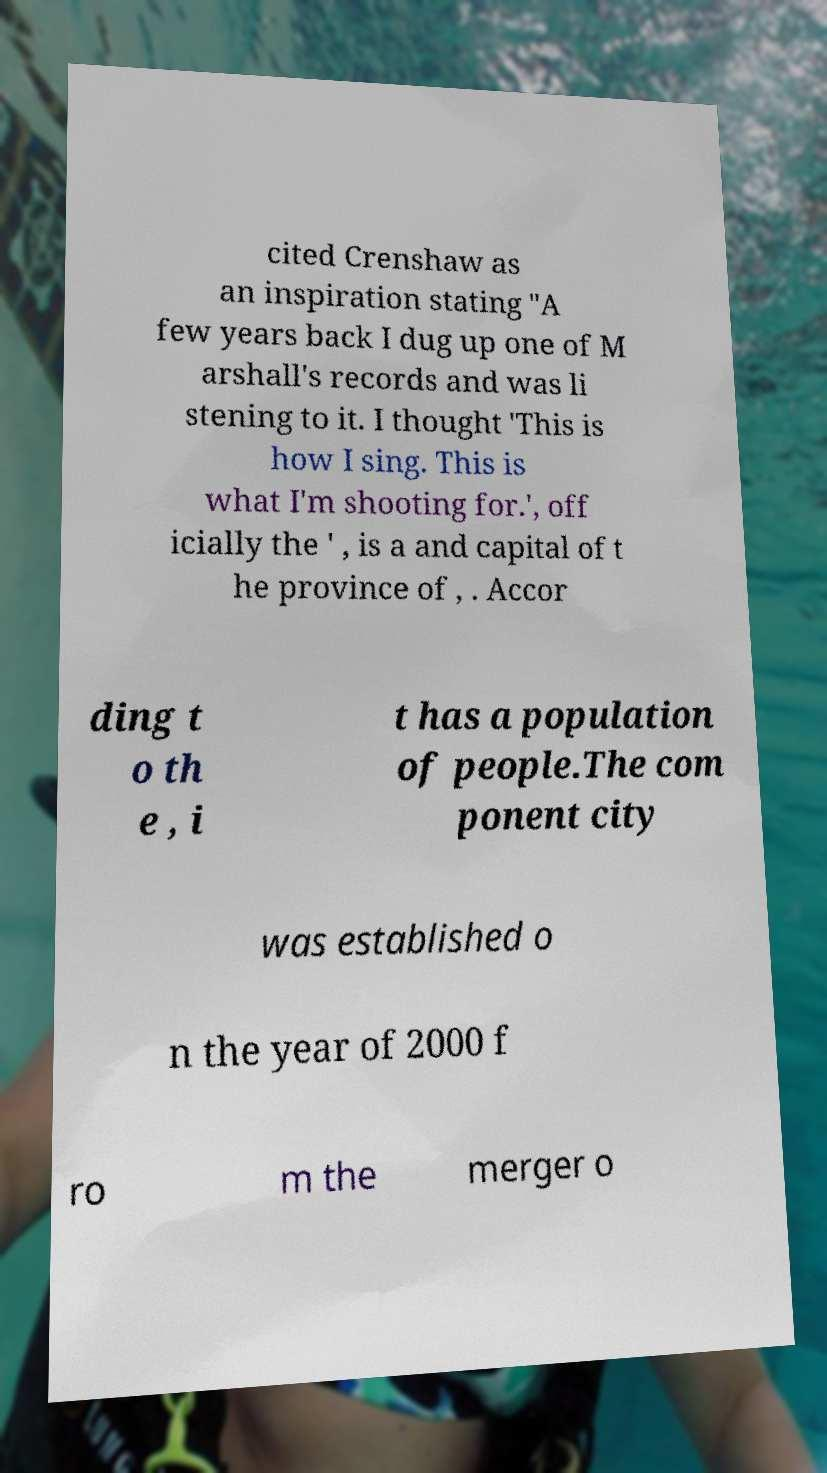Please identify and transcribe the text found in this image. cited Crenshaw as an inspiration stating "A few years back I dug up one of M arshall's records and was li stening to it. I thought 'This is how I sing. This is what I'm shooting for.', off icially the ' , is a and capital of t he province of , . Accor ding t o th e , i t has a population of people.The com ponent city was established o n the year of 2000 f ro m the merger o 